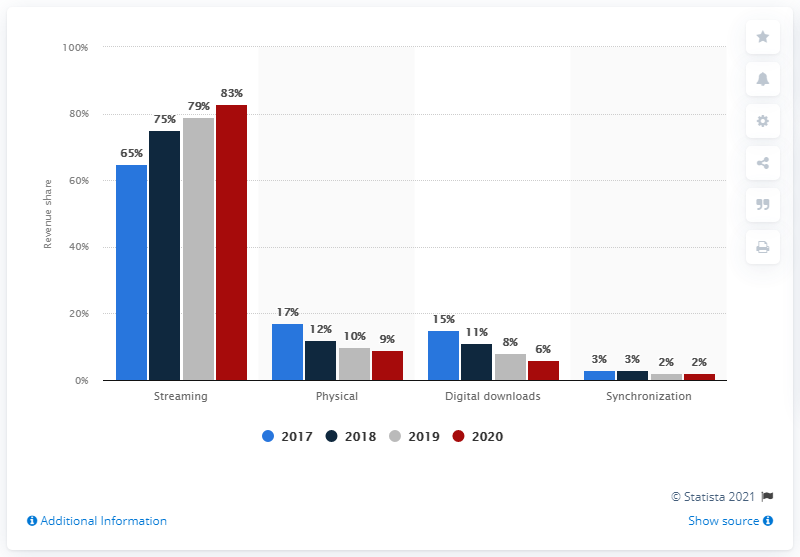Specify some key components in this picture. In 2020, streaming accounted for 83% of the total revenue generated by the U.S. music industry. In 2020, the music industry generated the majority of its revenue from streaming. In 2017, approximately 79% of the revenue generated by the U.S. music industry was derived from streaming. In 2020, streaming accounted for 83% of the U.S. music industry's total revenue. The industry's share of streaming revenue increased by 4% from 2019 to 2020. 